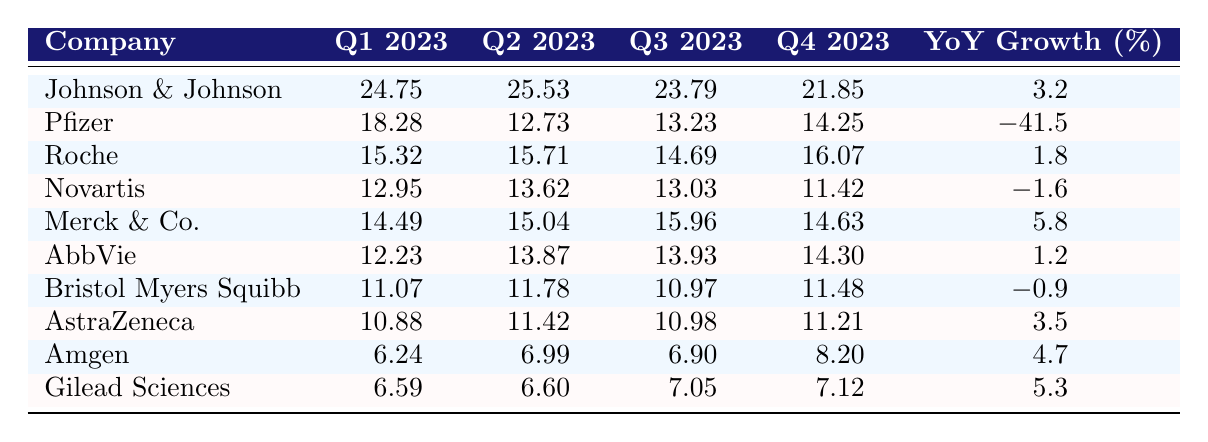What is the highest revenue recorded in Q1 2023? Looking at the table, Johnson & Johnson has the highest revenue in Q1 2023 at $24.75 billion.
Answer: $24.75 billion Which company experienced the most significant year-over-year growth? Reviewing the YoY Growth column, Merck & Co. has the highest growth rate at 5.8%.
Answer: Merck & Co What is the sum of revenues for Roche in 2023? Adding Roche's revenues: Q1 ($15.32B) + Q2 ($15.71B) + Q3 ($14.69B) + Q4 ($16.07B) = $61.79 billion.
Answer: $61.79 billion Did Pfizer's revenue increase in Q2 2023 compared to Q1 2023? Checking the values, Pfizer's Q2 revenue ($12.73B) decreased from Q1 ($18.28B).
Answer: No Which company's Q4 revenue is the lowest? Comparing Q4 revenues, Novartis has the lowest Q4 revenue at $11.42 billion.
Answer: Novartis What is the average revenue for Amgen over the four quarters? Amgen's revenues are: Q1 ($6.24B), Q2 ($6.99B), Q3 ($6.90B), Q4 ($8.20B). The sum: $6.24B + $6.99B + $6.90B + $8.20B = $28.33 billion, divided by 4 equals $7.08 billion.
Answer: $7.08 billion Is it true that Gilead Sciences recorded revenue above $7 billion in any quarter? Looking at Gilead's quarterly revenues, their highest was $7.12 billion in Q4, confirming the statement is true.
Answer: Yes What was the revenue difference between Q1 and Q4 for Johnson & Johnson? Johnson & Johnson's revenues are: Q1 ($24.75B) - Q4 ($21.85B) = a difference of $2.90 billion.
Answer: $2.90 billion Which two companies had negative YoY growth? From the table, Pfizer (-41.5%) and Novartis (-1.6%) both show negative growth.
Answer: Pfizer and Novartis How many companies had revenues above $15 billion in Q1 2023? Checking the Q1 column, the companies are Johnson & Johnson, Pfizer, and Roche, totaling three companies above $15 billion.
Answer: 3 